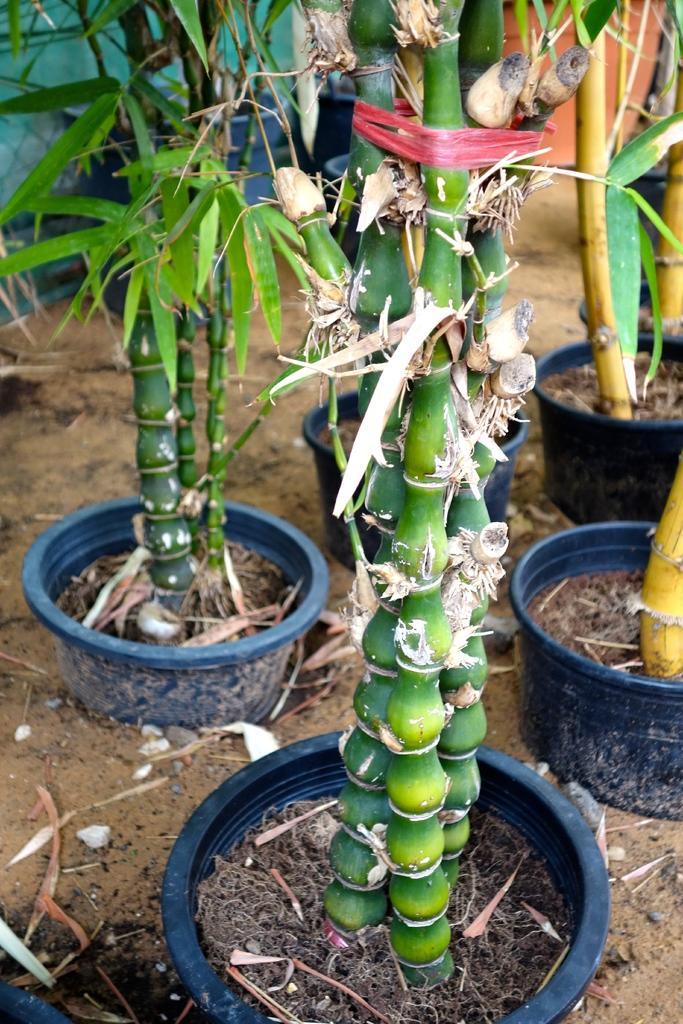Please provide a concise description of this image. In this image, we can see few plants with pots. Here there is a ground. Background we can see some object. 